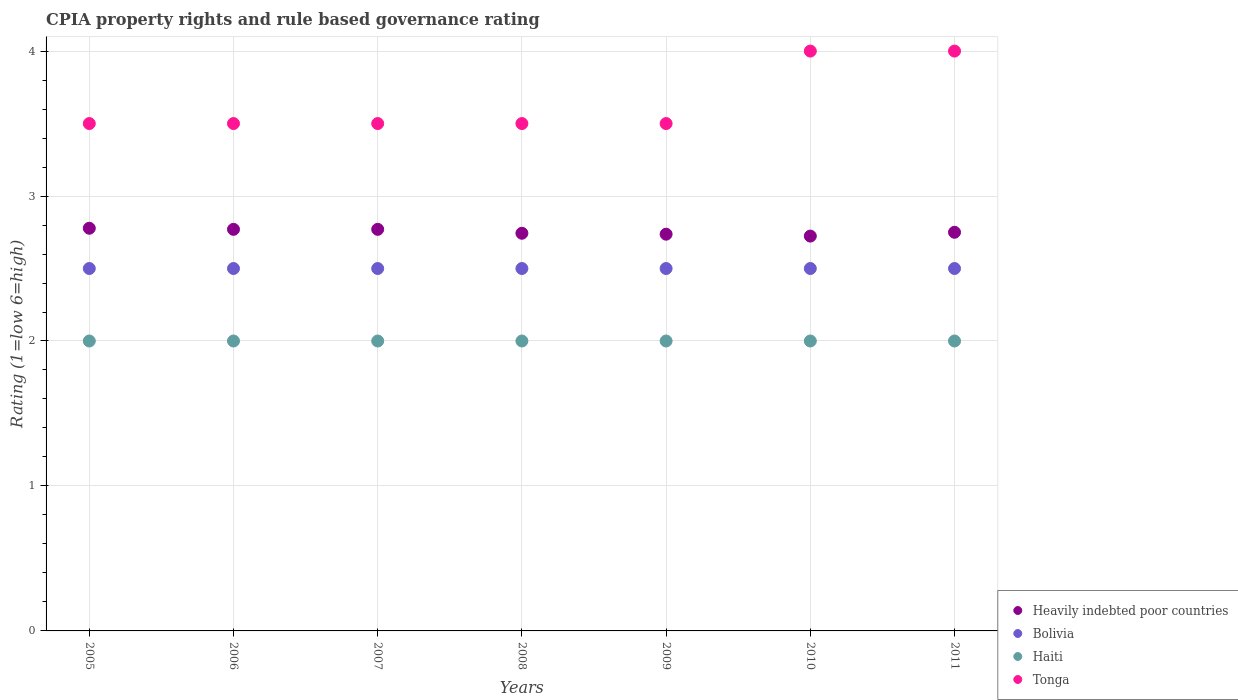What is the CPIA rating in Heavily indebted poor countries in 2005?
Give a very brief answer. 2.78. Across all years, what is the maximum CPIA rating in Bolivia?
Your answer should be very brief. 2.5. Across all years, what is the minimum CPIA rating in Heavily indebted poor countries?
Give a very brief answer. 2.72. In which year was the CPIA rating in Tonga maximum?
Offer a very short reply. 2010. In which year was the CPIA rating in Tonga minimum?
Give a very brief answer. 2005. What is the difference between the CPIA rating in Heavily indebted poor countries in 2005 and that in 2006?
Provide a succinct answer. 0.01. What is the difference between the CPIA rating in Tonga in 2006 and the CPIA rating in Haiti in 2008?
Provide a short and direct response. 1.5. What is the average CPIA rating in Haiti per year?
Your response must be concise. 2. In the year 2009, what is the difference between the CPIA rating in Tonga and CPIA rating in Heavily indebted poor countries?
Ensure brevity in your answer.  0.76. In how many years, is the CPIA rating in Bolivia greater than 3?
Provide a short and direct response. 0. What is the ratio of the CPIA rating in Heavily indebted poor countries in 2006 to that in 2010?
Offer a terse response. 1.02. Is the CPIA rating in Haiti in 2006 less than that in 2011?
Provide a short and direct response. No. Is the difference between the CPIA rating in Tonga in 2005 and 2006 greater than the difference between the CPIA rating in Heavily indebted poor countries in 2005 and 2006?
Keep it short and to the point. No. What is the difference between the highest and the lowest CPIA rating in Haiti?
Provide a succinct answer. 0. Is it the case that in every year, the sum of the CPIA rating in Heavily indebted poor countries and CPIA rating in Haiti  is greater than the sum of CPIA rating in Tonga and CPIA rating in Bolivia?
Provide a short and direct response. No. Is it the case that in every year, the sum of the CPIA rating in Heavily indebted poor countries and CPIA rating in Bolivia  is greater than the CPIA rating in Tonga?
Your response must be concise. Yes. Is the CPIA rating in Tonga strictly greater than the CPIA rating in Heavily indebted poor countries over the years?
Offer a terse response. Yes. Is the CPIA rating in Heavily indebted poor countries strictly less than the CPIA rating in Haiti over the years?
Make the answer very short. No. How many years are there in the graph?
Ensure brevity in your answer.  7. What is the difference between two consecutive major ticks on the Y-axis?
Offer a very short reply. 1. Are the values on the major ticks of Y-axis written in scientific E-notation?
Your response must be concise. No. Where does the legend appear in the graph?
Offer a terse response. Bottom right. How are the legend labels stacked?
Your answer should be compact. Vertical. What is the title of the graph?
Your response must be concise. CPIA property rights and rule based governance rating. What is the label or title of the X-axis?
Provide a short and direct response. Years. What is the Rating (1=low 6=high) in Heavily indebted poor countries in 2005?
Offer a very short reply. 2.78. What is the Rating (1=low 6=high) of Tonga in 2005?
Provide a short and direct response. 3.5. What is the Rating (1=low 6=high) of Heavily indebted poor countries in 2006?
Your response must be concise. 2.77. What is the Rating (1=low 6=high) in Haiti in 2006?
Keep it short and to the point. 2. What is the Rating (1=low 6=high) in Heavily indebted poor countries in 2007?
Provide a short and direct response. 2.77. What is the Rating (1=low 6=high) of Bolivia in 2007?
Give a very brief answer. 2.5. What is the Rating (1=low 6=high) in Haiti in 2007?
Provide a short and direct response. 2. What is the Rating (1=low 6=high) in Heavily indebted poor countries in 2008?
Offer a terse response. 2.74. What is the Rating (1=low 6=high) in Haiti in 2008?
Provide a short and direct response. 2. What is the Rating (1=low 6=high) in Tonga in 2008?
Your answer should be very brief. 3.5. What is the Rating (1=low 6=high) in Heavily indebted poor countries in 2009?
Your response must be concise. 2.74. What is the Rating (1=low 6=high) of Tonga in 2009?
Ensure brevity in your answer.  3.5. What is the Rating (1=low 6=high) of Heavily indebted poor countries in 2010?
Your answer should be very brief. 2.72. What is the Rating (1=low 6=high) of Haiti in 2010?
Ensure brevity in your answer.  2. What is the Rating (1=low 6=high) in Tonga in 2010?
Your response must be concise. 4. What is the Rating (1=low 6=high) in Heavily indebted poor countries in 2011?
Offer a very short reply. 2.75. What is the Rating (1=low 6=high) of Tonga in 2011?
Keep it short and to the point. 4. Across all years, what is the maximum Rating (1=low 6=high) of Heavily indebted poor countries?
Offer a very short reply. 2.78. Across all years, what is the maximum Rating (1=low 6=high) of Haiti?
Make the answer very short. 2. Across all years, what is the maximum Rating (1=low 6=high) of Tonga?
Keep it short and to the point. 4. Across all years, what is the minimum Rating (1=low 6=high) in Heavily indebted poor countries?
Ensure brevity in your answer.  2.72. Across all years, what is the minimum Rating (1=low 6=high) of Bolivia?
Offer a very short reply. 2.5. What is the total Rating (1=low 6=high) of Heavily indebted poor countries in the graph?
Give a very brief answer. 19.27. What is the difference between the Rating (1=low 6=high) of Heavily indebted poor countries in 2005 and that in 2006?
Offer a terse response. 0.01. What is the difference between the Rating (1=low 6=high) of Tonga in 2005 and that in 2006?
Offer a very short reply. 0. What is the difference between the Rating (1=low 6=high) of Heavily indebted poor countries in 2005 and that in 2007?
Provide a short and direct response. 0.01. What is the difference between the Rating (1=low 6=high) in Bolivia in 2005 and that in 2007?
Offer a terse response. 0. What is the difference between the Rating (1=low 6=high) of Haiti in 2005 and that in 2007?
Ensure brevity in your answer.  0. What is the difference between the Rating (1=low 6=high) of Heavily indebted poor countries in 2005 and that in 2008?
Give a very brief answer. 0.03. What is the difference between the Rating (1=low 6=high) in Haiti in 2005 and that in 2008?
Offer a terse response. 0. What is the difference between the Rating (1=low 6=high) of Tonga in 2005 and that in 2008?
Provide a short and direct response. 0. What is the difference between the Rating (1=low 6=high) of Heavily indebted poor countries in 2005 and that in 2009?
Make the answer very short. 0.04. What is the difference between the Rating (1=low 6=high) of Haiti in 2005 and that in 2009?
Your response must be concise. 0. What is the difference between the Rating (1=low 6=high) in Heavily indebted poor countries in 2005 and that in 2010?
Keep it short and to the point. 0.05. What is the difference between the Rating (1=low 6=high) of Heavily indebted poor countries in 2005 and that in 2011?
Offer a very short reply. 0.03. What is the difference between the Rating (1=low 6=high) in Tonga in 2005 and that in 2011?
Give a very brief answer. -0.5. What is the difference between the Rating (1=low 6=high) in Heavily indebted poor countries in 2006 and that in 2007?
Offer a terse response. 0. What is the difference between the Rating (1=low 6=high) of Bolivia in 2006 and that in 2007?
Provide a succinct answer. 0. What is the difference between the Rating (1=low 6=high) in Haiti in 2006 and that in 2007?
Your answer should be compact. 0. What is the difference between the Rating (1=low 6=high) of Heavily indebted poor countries in 2006 and that in 2008?
Provide a succinct answer. 0.03. What is the difference between the Rating (1=low 6=high) in Bolivia in 2006 and that in 2008?
Provide a succinct answer. 0. What is the difference between the Rating (1=low 6=high) in Tonga in 2006 and that in 2008?
Your response must be concise. 0. What is the difference between the Rating (1=low 6=high) of Heavily indebted poor countries in 2006 and that in 2009?
Your answer should be very brief. 0.03. What is the difference between the Rating (1=low 6=high) of Tonga in 2006 and that in 2009?
Offer a terse response. 0. What is the difference between the Rating (1=low 6=high) of Heavily indebted poor countries in 2006 and that in 2010?
Ensure brevity in your answer.  0.05. What is the difference between the Rating (1=low 6=high) of Bolivia in 2006 and that in 2010?
Your answer should be very brief. 0. What is the difference between the Rating (1=low 6=high) of Haiti in 2006 and that in 2010?
Keep it short and to the point. 0. What is the difference between the Rating (1=low 6=high) in Heavily indebted poor countries in 2006 and that in 2011?
Your response must be concise. 0.02. What is the difference between the Rating (1=low 6=high) of Tonga in 2006 and that in 2011?
Give a very brief answer. -0.5. What is the difference between the Rating (1=low 6=high) of Heavily indebted poor countries in 2007 and that in 2008?
Make the answer very short. 0.03. What is the difference between the Rating (1=low 6=high) of Haiti in 2007 and that in 2008?
Make the answer very short. 0. What is the difference between the Rating (1=low 6=high) of Tonga in 2007 and that in 2008?
Ensure brevity in your answer.  0. What is the difference between the Rating (1=low 6=high) in Heavily indebted poor countries in 2007 and that in 2009?
Make the answer very short. 0.03. What is the difference between the Rating (1=low 6=high) in Bolivia in 2007 and that in 2009?
Provide a short and direct response. 0. What is the difference between the Rating (1=low 6=high) of Tonga in 2007 and that in 2009?
Your answer should be very brief. 0. What is the difference between the Rating (1=low 6=high) in Heavily indebted poor countries in 2007 and that in 2010?
Provide a short and direct response. 0.05. What is the difference between the Rating (1=low 6=high) of Heavily indebted poor countries in 2007 and that in 2011?
Make the answer very short. 0.02. What is the difference between the Rating (1=low 6=high) in Haiti in 2007 and that in 2011?
Your answer should be compact. 0. What is the difference between the Rating (1=low 6=high) in Heavily indebted poor countries in 2008 and that in 2009?
Provide a short and direct response. 0.01. What is the difference between the Rating (1=low 6=high) in Haiti in 2008 and that in 2009?
Keep it short and to the point. 0. What is the difference between the Rating (1=low 6=high) in Tonga in 2008 and that in 2009?
Make the answer very short. 0. What is the difference between the Rating (1=low 6=high) of Heavily indebted poor countries in 2008 and that in 2010?
Offer a very short reply. 0.02. What is the difference between the Rating (1=low 6=high) of Heavily indebted poor countries in 2008 and that in 2011?
Provide a succinct answer. -0.01. What is the difference between the Rating (1=low 6=high) of Haiti in 2008 and that in 2011?
Your answer should be very brief. 0. What is the difference between the Rating (1=low 6=high) in Tonga in 2008 and that in 2011?
Offer a very short reply. -0.5. What is the difference between the Rating (1=low 6=high) in Heavily indebted poor countries in 2009 and that in 2010?
Keep it short and to the point. 0.01. What is the difference between the Rating (1=low 6=high) of Haiti in 2009 and that in 2010?
Give a very brief answer. 0. What is the difference between the Rating (1=low 6=high) in Tonga in 2009 and that in 2010?
Provide a succinct answer. -0.5. What is the difference between the Rating (1=low 6=high) in Heavily indebted poor countries in 2009 and that in 2011?
Give a very brief answer. -0.01. What is the difference between the Rating (1=low 6=high) of Tonga in 2009 and that in 2011?
Your answer should be compact. -0.5. What is the difference between the Rating (1=low 6=high) of Heavily indebted poor countries in 2010 and that in 2011?
Your answer should be very brief. -0.03. What is the difference between the Rating (1=low 6=high) in Bolivia in 2010 and that in 2011?
Your answer should be compact. 0. What is the difference between the Rating (1=low 6=high) in Tonga in 2010 and that in 2011?
Your answer should be compact. 0. What is the difference between the Rating (1=low 6=high) in Heavily indebted poor countries in 2005 and the Rating (1=low 6=high) in Bolivia in 2006?
Ensure brevity in your answer.  0.28. What is the difference between the Rating (1=low 6=high) of Heavily indebted poor countries in 2005 and the Rating (1=low 6=high) of Tonga in 2006?
Make the answer very short. -0.72. What is the difference between the Rating (1=low 6=high) of Bolivia in 2005 and the Rating (1=low 6=high) of Haiti in 2006?
Ensure brevity in your answer.  0.5. What is the difference between the Rating (1=low 6=high) of Bolivia in 2005 and the Rating (1=low 6=high) of Tonga in 2006?
Provide a short and direct response. -1. What is the difference between the Rating (1=low 6=high) of Haiti in 2005 and the Rating (1=low 6=high) of Tonga in 2006?
Keep it short and to the point. -1.5. What is the difference between the Rating (1=low 6=high) in Heavily indebted poor countries in 2005 and the Rating (1=low 6=high) in Bolivia in 2007?
Provide a succinct answer. 0.28. What is the difference between the Rating (1=low 6=high) in Heavily indebted poor countries in 2005 and the Rating (1=low 6=high) in Tonga in 2007?
Your response must be concise. -0.72. What is the difference between the Rating (1=low 6=high) of Bolivia in 2005 and the Rating (1=low 6=high) of Haiti in 2007?
Give a very brief answer. 0.5. What is the difference between the Rating (1=low 6=high) of Heavily indebted poor countries in 2005 and the Rating (1=low 6=high) of Bolivia in 2008?
Ensure brevity in your answer.  0.28. What is the difference between the Rating (1=low 6=high) in Heavily indebted poor countries in 2005 and the Rating (1=low 6=high) in Haiti in 2008?
Make the answer very short. 0.78. What is the difference between the Rating (1=low 6=high) of Heavily indebted poor countries in 2005 and the Rating (1=low 6=high) of Tonga in 2008?
Your answer should be very brief. -0.72. What is the difference between the Rating (1=low 6=high) of Haiti in 2005 and the Rating (1=low 6=high) of Tonga in 2008?
Your response must be concise. -1.5. What is the difference between the Rating (1=low 6=high) of Heavily indebted poor countries in 2005 and the Rating (1=low 6=high) of Bolivia in 2009?
Make the answer very short. 0.28. What is the difference between the Rating (1=low 6=high) in Heavily indebted poor countries in 2005 and the Rating (1=low 6=high) in Haiti in 2009?
Your response must be concise. 0.78. What is the difference between the Rating (1=low 6=high) of Heavily indebted poor countries in 2005 and the Rating (1=low 6=high) of Tonga in 2009?
Keep it short and to the point. -0.72. What is the difference between the Rating (1=low 6=high) in Bolivia in 2005 and the Rating (1=low 6=high) in Tonga in 2009?
Provide a succinct answer. -1. What is the difference between the Rating (1=low 6=high) in Haiti in 2005 and the Rating (1=low 6=high) in Tonga in 2009?
Your answer should be very brief. -1.5. What is the difference between the Rating (1=low 6=high) in Heavily indebted poor countries in 2005 and the Rating (1=low 6=high) in Bolivia in 2010?
Ensure brevity in your answer.  0.28. What is the difference between the Rating (1=low 6=high) of Heavily indebted poor countries in 2005 and the Rating (1=low 6=high) of Tonga in 2010?
Your response must be concise. -1.22. What is the difference between the Rating (1=low 6=high) in Bolivia in 2005 and the Rating (1=low 6=high) in Tonga in 2010?
Offer a terse response. -1.5. What is the difference between the Rating (1=low 6=high) of Heavily indebted poor countries in 2005 and the Rating (1=low 6=high) of Bolivia in 2011?
Make the answer very short. 0.28. What is the difference between the Rating (1=low 6=high) of Heavily indebted poor countries in 2005 and the Rating (1=low 6=high) of Haiti in 2011?
Give a very brief answer. 0.78. What is the difference between the Rating (1=low 6=high) of Heavily indebted poor countries in 2005 and the Rating (1=low 6=high) of Tonga in 2011?
Provide a short and direct response. -1.22. What is the difference between the Rating (1=low 6=high) in Bolivia in 2005 and the Rating (1=low 6=high) in Haiti in 2011?
Offer a terse response. 0.5. What is the difference between the Rating (1=low 6=high) of Haiti in 2005 and the Rating (1=low 6=high) of Tonga in 2011?
Offer a very short reply. -2. What is the difference between the Rating (1=low 6=high) of Heavily indebted poor countries in 2006 and the Rating (1=low 6=high) of Bolivia in 2007?
Provide a short and direct response. 0.27. What is the difference between the Rating (1=low 6=high) in Heavily indebted poor countries in 2006 and the Rating (1=low 6=high) in Haiti in 2007?
Your response must be concise. 0.77. What is the difference between the Rating (1=low 6=high) of Heavily indebted poor countries in 2006 and the Rating (1=low 6=high) of Tonga in 2007?
Your answer should be compact. -0.73. What is the difference between the Rating (1=low 6=high) of Bolivia in 2006 and the Rating (1=low 6=high) of Haiti in 2007?
Provide a short and direct response. 0.5. What is the difference between the Rating (1=low 6=high) of Bolivia in 2006 and the Rating (1=low 6=high) of Tonga in 2007?
Offer a terse response. -1. What is the difference between the Rating (1=low 6=high) in Heavily indebted poor countries in 2006 and the Rating (1=low 6=high) in Bolivia in 2008?
Your response must be concise. 0.27. What is the difference between the Rating (1=low 6=high) in Heavily indebted poor countries in 2006 and the Rating (1=low 6=high) in Haiti in 2008?
Provide a succinct answer. 0.77. What is the difference between the Rating (1=low 6=high) of Heavily indebted poor countries in 2006 and the Rating (1=low 6=high) of Tonga in 2008?
Offer a very short reply. -0.73. What is the difference between the Rating (1=low 6=high) in Bolivia in 2006 and the Rating (1=low 6=high) in Haiti in 2008?
Your response must be concise. 0.5. What is the difference between the Rating (1=low 6=high) of Bolivia in 2006 and the Rating (1=low 6=high) of Tonga in 2008?
Your answer should be compact. -1. What is the difference between the Rating (1=low 6=high) in Haiti in 2006 and the Rating (1=low 6=high) in Tonga in 2008?
Your answer should be compact. -1.5. What is the difference between the Rating (1=low 6=high) of Heavily indebted poor countries in 2006 and the Rating (1=low 6=high) of Bolivia in 2009?
Keep it short and to the point. 0.27. What is the difference between the Rating (1=low 6=high) in Heavily indebted poor countries in 2006 and the Rating (1=low 6=high) in Haiti in 2009?
Give a very brief answer. 0.77. What is the difference between the Rating (1=low 6=high) of Heavily indebted poor countries in 2006 and the Rating (1=low 6=high) of Tonga in 2009?
Offer a very short reply. -0.73. What is the difference between the Rating (1=low 6=high) in Haiti in 2006 and the Rating (1=low 6=high) in Tonga in 2009?
Offer a very short reply. -1.5. What is the difference between the Rating (1=low 6=high) in Heavily indebted poor countries in 2006 and the Rating (1=low 6=high) in Bolivia in 2010?
Ensure brevity in your answer.  0.27. What is the difference between the Rating (1=low 6=high) in Heavily indebted poor countries in 2006 and the Rating (1=low 6=high) in Haiti in 2010?
Offer a very short reply. 0.77. What is the difference between the Rating (1=low 6=high) in Heavily indebted poor countries in 2006 and the Rating (1=low 6=high) in Tonga in 2010?
Ensure brevity in your answer.  -1.23. What is the difference between the Rating (1=low 6=high) in Bolivia in 2006 and the Rating (1=low 6=high) in Haiti in 2010?
Ensure brevity in your answer.  0.5. What is the difference between the Rating (1=low 6=high) in Haiti in 2006 and the Rating (1=low 6=high) in Tonga in 2010?
Make the answer very short. -2. What is the difference between the Rating (1=low 6=high) of Heavily indebted poor countries in 2006 and the Rating (1=low 6=high) of Bolivia in 2011?
Offer a terse response. 0.27. What is the difference between the Rating (1=low 6=high) of Heavily indebted poor countries in 2006 and the Rating (1=low 6=high) of Haiti in 2011?
Ensure brevity in your answer.  0.77. What is the difference between the Rating (1=low 6=high) in Heavily indebted poor countries in 2006 and the Rating (1=low 6=high) in Tonga in 2011?
Make the answer very short. -1.23. What is the difference between the Rating (1=low 6=high) in Bolivia in 2006 and the Rating (1=low 6=high) in Haiti in 2011?
Your answer should be very brief. 0.5. What is the difference between the Rating (1=low 6=high) in Bolivia in 2006 and the Rating (1=low 6=high) in Tonga in 2011?
Offer a terse response. -1.5. What is the difference between the Rating (1=low 6=high) of Haiti in 2006 and the Rating (1=low 6=high) of Tonga in 2011?
Provide a succinct answer. -2. What is the difference between the Rating (1=low 6=high) of Heavily indebted poor countries in 2007 and the Rating (1=low 6=high) of Bolivia in 2008?
Ensure brevity in your answer.  0.27. What is the difference between the Rating (1=low 6=high) of Heavily indebted poor countries in 2007 and the Rating (1=low 6=high) of Haiti in 2008?
Provide a succinct answer. 0.77. What is the difference between the Rating (1=low 6=high) of Heavily indebted poor countries in 2007 and the Rating (1=low 6=high) of Tonga in 2008?
Ensure brevity in your answer.  -0.73. What is the difference between the Rating (1=low 6=high) in Bolivia in 2007 and the Rating (1=low 6=high) in Haiti in 2008?
Your answer should be very brief. 0.5. What is the difference between the Rating (1=low 6=high) in Bolivia in 2007 and the Rating (1=low 6=high) in Tonga in 2008?
Your answer should be compact. -1. What is the difference between the Rating (1=low 6=high) of Haiti in 2007 and the Rating (1=low 6=high) of Tonga in 2008?
Your answer should be very brief. -1.5. What is the difference between the Rating (1=low 6=high) of Heavily indebted poor countries in 2007 and the Rating (1=low 6=high) of Bolivia in 2009?
Provide a succinct answer. 0.27. What is the difference between the Rating (1=low 6=high) in Heavily indebted poor countries in 2007 and the Rating (1=low 6=high) in Haiti in 2009?
Ensure brevity in your answer.  0.77. What is the difference between the Rating (1=low 6=high) of Heavily indebted poor countries in 2007 and the Rating (1=low 6=high) of Tonga in 2009?
Your answer should be compact. -0.73. What is the difference between the Rating (1=low 6=high) in Bolivia in 2007 and the Rating (1=low 6=high) in Haiti in 2009?
Your response must be concise. 0.5. What is the difference between the Rating (1=low 6=high) of Bolivia in 2007 and the Rating (1=low 6=high) of Tonga in 2009?
Keep it short and to the point. -1. What is the difference between the Rating (1=low 6=high) in Heavily indebted poor countries in 2007 and the Rating (1=low 6=high) in Bolivia in 2010?
Your answer should be compact. 0.27. What is the difference between the Rating (1=low 6=high) in Heavily indebted poor countries in 2007 and the Rating (1=low 6=high) in Haiti in 2010?
Make the answer very short. 0.77. What is the difference between the Rating (1=low 6=high) of Heavily indebted poor countries in 2007 and the Rating (1=low 6=high) of Tonga in 2010?
Your response must be concise. -1.23. What is the difference between the Rating (1=low 6=high) in Bolivia in 2007 and the Rating (1=low 6=high) in Tonga in 2010?
Ensure brevity in your answer.  -1.5. What is the difference between the Rating (1=low 6=high) of Heavily indebted poor countries in 2007 and the Rating (1=low 6=high) of Bolivia in 2011?
Give a very brief answer. 0.27. What is the difference between the Rating (1=low 6=high) in Heavily indebted poor countries in 2007 and the Rating (1=low 6=high) in Haiti in 2011?
Your answer should be compact. 0.77. What is the difference between the Rating (1=low 6=high) in Heavily indebted poor countries in 2007 and the Rating (1=low 6=high) in Tonga in 2011?
Your response must be concise. -1.23. What is the difference between the Rating (1=low 6=high) in Bolivia in 2007 and the Rating (1=low 6=high) in Tonga in 2011?
Provide a short and direct response. -1.5. What is the difference between the Rating (1=low 6=high) of Haiti in 2007 and the Rating (1=low 6=high) of Tonga in 2011?
Keep it short and to the point. -2. What is the difference between the Rating (1=low 6=high) in Heavily indebted poor countries in 2008 and the Rating (1=low 6=high) in Bolivia in 2009?
Give a very brief answer. 0.24. What is the difference between the Rating (1=low 6=high) of Heavily indebted poor countries in 2008 and the Rating (1=low 6=high) of Haiti in 2009?
Your answer should be very brief. 0.74. What is the difference between the Rating (1=low 6=high) of Heavily indebted poor countries in 2008 and the Rating (1=low 6=high) of Tonga in 2009?
Your answer should be very brief. -0.76. What is the difference between the Rating (1=low 6=high) in Bolivia in 2008 and the Rating (1=low 6=high) in Haiti in 2009?
Your response must be concise. 0.5. What is the difference between the Rating (1=low 6=high) in Heavily indebted poor countries in 2008 and the Rating (1=low 6=high) in Bolivia in 2010?
Keep it short and to the point. 0.24. What is the difference between the Rating (1=low 6=high) in Heavily indebted poor countries in 2008 and the Rating (1=low 6=high) in Haiti in 2010?
Provide a succinct answer. 0.74. What is the difference between the Rating (1=low 6=high) of Heavily indebted poor countries in 2008 and the Rating (1=low 6=high) of Tonga in 2010?
Ensure brevity in your answer.  -1.26. What is the difference between the Rating (1=low 6=high) of Bolivia in 2008 and the Rating (1=low 6=high) of Haiti in 2010?
Offer a terse response. 0.5. What is the difference between the Rating (1=low 6=high) in Haiti in 2008 and the Rating (1=low 6=high) in Tonga in 2010?
Provide a short and direct response. -2. What is the difference between the Rating (1=low 6=high) in Heavily indebted poor countries in 2008 and the Rating (1=low 6=high) in Bolivia in 2011?
Make the answer very short. 0.24. What is the difference between the Rating (1=low 6=high) in Heavily indebted poor countries in 2008 and the Rating (1=low 6=high) in Haiti in 2011?
Offer a very short reply. 0.74. What is the difference between the Rating (1=low 6=high) of Heavily indebted poor countries in 2008 and the Rating (1=low 6=high) of Tonga in 2011?
Keep it short and to the point. -1.26. What is the difference between the Rating (1=low 6=high) in Bolivia in 2008 and the Rating (1=low 6=high) in Tonga in 2011?
Your answer should be compact. -1.5. What is the difference between the Rating (1=low 6=high) in Haiti in 2008 and the Rating (1=low 6=high) in Tonga in 2011?
Your answer should be compact. -2. What is the difference between the Rating (1=low 6=high) in Heavily indebted poor countries in 2009 and the Rating (1=low 6=high) in Bolivia in 2010?
Your answer should be compact. 0.24. What is the difference between the Rating (1=low 6=high) of Heavily indebted poor countries in 2009 and the Rating (1=low 6=high) of Haiti in 2010?
Offer a terse response. 0.74. What is the difference between the Rating (1=low 6=high) in Heavily indebted poor countries in 2009 and the Rating (1=low 6=high) in Tonga in 2010?
Your answer should be compact. -1.26. What is the difference between the Rating (1=low 6=high) of Bolivia in 2009 and the Rating (1=low 6=high) of Haiti in 2010?
Your answer should be very brief. 0.5. What is the difference between the Rating (1=low 6=high) in Haiti in 2009 and the Rating (1=low 6=high) in Tonga in 2010?
Offer a terse response. -2. What is the difference between the Rating (1=low 6=high) of Heavily indebted poor countries in 2009 and the Rating (1=low 6=high) of Bolivia in 2011?
Your answer should be very brief. 0.24. What is the difference between the Rating (1=low 6=high) of Heavily indebted poor countries in 2009 and the Rating (1=low 6=high) of Haiti in 2011?
Offer a very short reply. 0.74. What is the difference between the Rating (1=low 6=high) in Heavily indebted poor countries in 2009 and the Rating (1=low 6=high) in Tonga in 2011?
Provide a succinct answer. -1.26. What is the difference between the Rating (1=low 6=high) of Bolivia in 2009 and the Rating (1=low 6=high) of Haiti in 2011?
Your answer should be very brief. 0.5. What is the difference between the Rating (1=low 6=high) in Bolivia in 2009 and the Rating (1=low 6=high) in Tonga in 2011?
Provide a succinct answer. -1.5. What is the difference between the Rating (1=low 6=high) in Haiti in 2009 and the Rating (1=low 6=high) in Tonga in 2011?
Your response must be concise. -2. What is the difference between the Rating (1=low 6=high) of Heavily indebted poor countries in 2010 and the Rating (1=low 6=high) of Bolivia in 2011?
Make the answer very short. 0.22. What is the difference between the Rating (1=low 6=high) in Heavily indebted poor countries in 2010 and the Rating (1=low 6=high) in Haiti in 2011?
Offer a very short reply. 0.72. What is the difference between the Rating (1=low 6=high) of Heavily indebted poor countries in 2010 and the Rating (1=low 6=high) of Tonga in 2011?
Make the answer very short. -1.28. What is the difference between the Rating (1=low 6=high) of Bolivia in 2010 and the Rating (1=low 6=high) of Haiti in 2011?
Provide a succinct answer. 0.5. What is the difference between the Rating (1=low 6=high) in Bolivia in 2010 and the Rating (1=low 6=high) in Tonga in 2011?
Ensure brevity in your answer.  -1.5. What is the average Rating (1=low 6=high) of Heavily indebted poor countries per year?
Offer a terse response. 2.75. What is the average Rating (1=low 6=high) of Bolivia per year?
Your response must be concise. 2.5. What is the average Rating (1=low 6=high) of Haiti per year?
Give a very brief answer. 2. What is the average Rating (1=low 6=high) of Tonga per year?
Ensure brevity in your answer.  3.64. In the year 2005, what is the difference between the Rating (1=low 6=high) of Heavily indebted poor countries and Rating (1=low 6=high) of Bolivia?
Provide a short and direct response. 0.28. In the year 2005, what is the difference between the Rating (1=low 6=high) of Heavily indebted poor countries and Rating (1=low 6=high) of Tonga?
Your response must be concise. -0.72. In the year 2005, what is the difference between the Rating (1=low 6=high) of Bolivia and Rating (1=low 6=high) of Haiti?
Keep it short and to the point. 0.5. In the year 2005, what is the difference between the Rating (1=low 6=high) in Bolivia and Rating (1=low 6=high) in Tonga?
Offer a terse response. -1. In the year 2006, what is the difference between the Rating (1=low 6=high) in Heavily indebted poor countries and Rating (1=low 6=high) in Bolivia?
Your answer should be compact. 0.27. In the year 2006, what is the difference between the Rating (1=low 6=high) of Heavily indebted poor countries and Rating (1=low 6=high) of Haiti?
Your response must be concise. 0.77. In the year 2006, what is the difference between the Rating (1=low 6=high) in Heavily indebted poor countries and Rating (1=low 6=high) in Tonga?
Ensure brevity in your answer.  -0.73. In the year 2006, what is the difference between the Rating (1=low 6=high) of Bolivia and Rating (1=low 6=high) of Haiti?
Offer a very short reply. 0.5. In the year 2007, what is the difference between the Rating (1=low 6=high) in Heavily indebted poor countries and Rating (1=low 6=high) in Bolivia?
Your answer should be very brief. 0.27. In the year 2007, what is the difference between the Rating (1=low 6=high) in Heavily indebted poor countries and Rating (1=low 6=high) in Haiti?
Your answer should be very brief. 0.77. In the year 2007, what is the difference between the Rating (1=low 6=high) in Heavily indebted poor countries and Rating (1=low 6=high) in Tonga?
Your answer should be very brief. -0.73. In the year 2007, what is the difference between the Rating (1=low 6=high) of Bolivia and Rating (1=low 6=high) of Tonga?
Your response must be concise. -1. In the year 2007, what is the difference between the Rating (1=low 6=high) of Haiti and Rating (1=low 6=high) of Tonga?
Your response must be concise. -1.5. In the year 2008, what is the difference between the Rating (1=low 6=high) of Heavily indebted poor countries and Rating (1=low 6=high) of Bolivia?
Provide a short and direct response. 0.24. In the year 2008, what is the difference between the Rating (1=low 6=high) of Heavily indebted poor countries and Rating (1=low 6=high) of Haiti?
Give a very brief answer. 0.74. In the year 2008, what is the difference between the Rating (1=low 6=high) in Heavily indebted poor countries and Rating (1=low 6=high) in Tonga?
Your response must be concise. -0.76. In the year 2008, what is the difference between the Rating (1=low 6=high) of Bolivia and Rating (1=low 6=high) of Haiti?
Ensure brevity in your answer.  0.5. In the year 2008, what is the difference between the Rating (1=low 6=high) of Haiti and Rating (1=low 6=high) of Tonga?
Ensure brevity in your answer.  -1.5. In the year 2009, what is the difference between the Rating (1=low 6=high) in Heavily indebted poor countries and Rating (1=low 6=high) in Bolivia?
Your answer should be very brief. 0.24. In the year 2009, what is the difference between the Rating (1=low 6=high) in Heavily indebted poor countries and Rating (1=low 6=high) in Haiti?
Provide a short and direct response. 0.74. In the year 2009, what is the difference between the Rating (1=low 6=high) of Heavily indebted poor countries and Rating (1=low 6=high) of Tonga?
Give a very brief answer. -0.76. In the year 2010, what is the difference between the Rating (1=low 6=high) of Heavily indebted poor countries and Rating (1=low 6=high) of Bolivia?
Keep it short and to the point. 0.22. In the year 2010, what is the difference between the Rating (1=low 6=high) in Heavily indebted poor countries and Rating (1=low 6=high) in Haiti?
Provide a short and direct response. 0.72. In the year 2010, what is the difference between the Rating (1=low 6=high) in Heavily indebted poor countries and Rating (1=low 6=high) in Tonga?
Make the answer very short. -1.28. In the year 2010, what is the difference between the Rating (1=low 6=high) in Bolivia and Rating (1=low 6=high) in Tonga?
Offer a terse response. -1.5. In the year 2010, what is the difference between the Rating (1=low 6=high) in Haiti and Rating (1=low 6=high) in Tonga?
Your answer should be compact. -2. In the year 2011, what is the difference between the Rating (1=low 6=high) of Heavily indebted poor countries and Rating (1=low 6=high) of Bolivia?
Your answer should be compact. 0.25. In the year 2011, what is the difference between the Rating (1=low 6=high) in Heavily indebted poor countries and Rating (1=low 6=high) in Tonga?
Your answer should be compact. -1.25. In the year 2011, what is the difference between the Rating (1=low 6=high) of Bolivia and Rating (1=low 6=high) of Tonga?
Your answer should be compact. -1.5. What is the ratio of the Rating (1=low 6=high) in Bolivia in 2005 to that in 2006?
Offer a terse response. 1. What is the ratio of the Rating (1=low 6=high) in Haiti in 2005 to that in 2006?
Provide a succinct answer. 1. What is the ratio of the Rating (1=low 6=high) of Tonga in 2005 to that in 2006?
Make the answer very short. 1. What is the ratio of the Rating (1=low 6=high) of Bolivia in 2005 to that in 2007?
Ensure brevity in your answer.  1. What is the ratio of the Rating (1=low 6=high) in Heavily indebted poor countries in 2005 to that in 2008?
Your answer should be very brief. 1.01. What is the ratio of the Rating (1=low 6=high) of Bolivia in 2005 to that in 2008?
Your answer should be compact. 1. What is the ratio of the Rating (1=low 6=high) of Bolivia in 2005 to that in 2009?
Ensure brevity in your answer.  1. What is the ratio of the Rating (1=low 6=high) of Haiti in 2005 to that in 2009?
Offer a very short reply. 1. What is the ratio of the Rating (1=low 6=high) in Tonga in 2005 to that in 2009?
Offer a terse response. 1. What is the ratio of the Rating (1=low 6=high) in Heavily indebted poor countries in 2005 to that in 2010?
Your answer should be very brief. 1.02. What is the ratio of the Rating (1=low 6=high) of Bolivia in 2005 to that in 2010?
Offer a very short reply. 1. What is the ratio of the Rating (1=low 6=high) in Haiti in 2005 to that in 2011?
Provide a short and direct response. 1. What is the ratio of the Rating (1=low 6=high) in Tonga in 2005 to that in 2011?
Give a very brief answer. 0.88. What is the ratio of the Rating (1=low 6=high) of Heavily indebted poor countries in 2006 to that in 2007?
Ensure brevity in your answer.  1. What is the ratio of the Rating (1=low 6=high) of Tonga in 2006 to that in 2007?
Ensure brevity in your answer.  1. What is the ratio of the Rating (1=low 6=high) in Heavily indebted poor countries in 2006 to that in 2008?
Provide a short and direct response. 1.01. What is the ratio of the Rating (1=low 6=high) in Tonga in 2006 to that in 2008?
Your answer should be very brief. 1. What is the ratio of the Rating (1=low 6=high) in Heavily indebted poor countries in 2006 to that in 2009?
Your answer should be compact. 1.01. What is the ratio of the Rating (1=low 6=high) of Haiti in 2006 to that in 2009?
Provide a succinct answer. 1. What is the ratio of the Rating (1=low 6=high) in Heavily indebted poor countries in 2006 to that in 2010?
Keep it short and to the point. 1.02. What is the ratio of the Rating (1=low 6=high) in Bolivia in 2006 to that in 2010?
Your answer should be very brief. 1. What is the ratio of the Rating (1=low 6=high) in Heavily indebted poor countries in 2006 to that in 2011?
Keep it short and to the point. 1.01. What is the ratio of the Rating (1=low 6=high) in Bolivia in 2006 to that in 2011?
Offer a terse response. 1. What is the ratio of the Rating (1=low 6=high) of Heavily indebted poor countries in 2007 to that in 2008?
Provide a succinct answer. 1.01. What is the ratio of the Rating (1=low 6=high) in Haiti in 2007 to that in 2008?
Provide a short and direct response. 1. What is the ratio of the Rating (1=low 6=high) of Tonga in 2007 to that in 2008?
Your answer should be compact. 1. What is the ratio of the Rating (1=low 6=high) in Heavily indebted poor countries in 2007 to that in 2009?
Your response must be concise. 1.01. What is the ratio of the Rating (1=low 6=high) of Bolivia in 2007 to that in 2009?
Give a very brief answer. 1. What is the ratio of the Rating (1=low 6=high) of Heavily indebted poor countries in 2007 to that in 2010?
Offer a very short reply. 1.02. What is the ratio of the Rating (1=low 6=high) in Bolivia in 2007 to that in 2010?
Your answer should be compact. 1. What is the ratio of the Rating (1=low 6=high) of Heavily indebted poor countries in 2007 to that in 2011?
Your answer should be compact. 1.01. What is the ratio of the Rating (1=low 6=high) of Bolivia in 2007 to that in 2011?
Your response must be concise. 1. What is the ratio of the Rating (1=low 6=high) in Heavily indebted poor countries in 2008 to that in 2009?
Your response must be concise. 1. What is the ratio of the Rating (1=low 6=high) in Tonga in 2008 to that in 2009?
Provide a short and direct response. 1. What is the ratio of the Rating (1=low 6=high) of Heavily indebted poor countries in 2008 to that in 2010?
Your response must be concise. 1.01. What is the ratio of the Rating (1=low 6=high) of Haiti in 2008 to that in 2010?
Give a very brief answer. 1. What is the ratio of the Rating (1=low 6=high) of Tonga in 2008 to that in 2010?
Keep it short and to the point. 0.88. What is the ratio of the Rating (1=low 6=high) in Heavily indebted poor countries in 2009 to that in 2010?
Give a very brief answer. 1. What is the ratio of the Rating (1=low 6=high) in Bolivia in 2009 to that in 2010?
Ensure brevity in your answer.  1. What is the ratio of the Rating (1=low 6=high) of Haiti in 2009 to that in 2010?
Your answer should be compact. 1. What is the ratio of the Rating (1=low 6=high) in Heavily indebted poor countries in 2009 to that in 2011?
Give a very brief answer. 1. What is the ratio of the Rating (1=low 6=high) in Bolivia in 2009 to that in 2011?
Offer a very short reply. 1. What is the ratio of the Rating (1=low 6=high) in Heavily indebted poor countries in 2010 to that in 2011?
Your response must be concise. 0.99. What is the ratio of the Rating (1=low 6=high) of Haiti in 2010 to that in 2011?
Provide a short and direct response. 1. What is the difference between the highest and the second highest Rating (1=low 6=high) in Heavily indebted poor countries?
Ensure brevity in your answer.  0.01. What is the difference between the highest and the second highest Rating (1=low 6=high) in Tonga?
Provide a short and direct response. 0. What is the difference between the highest and the lowest Rating (1=low 6=high) in Heavily indebted poor countries?
Keep it short and to the point. 0.05. What is the difference between the highest and the lowest Rating (1=low 6=high) of Bolivia?
Provide a short and direct response. 0. What is the difference between the highest and the lowest Rating (1=low 6=high) in Haiti?
Ensure brevity in your answer.  0. What is the difference between the highest and the lowest Rating (1=low 6=high) in Tonga?
Offer a terse response. 0.5. 